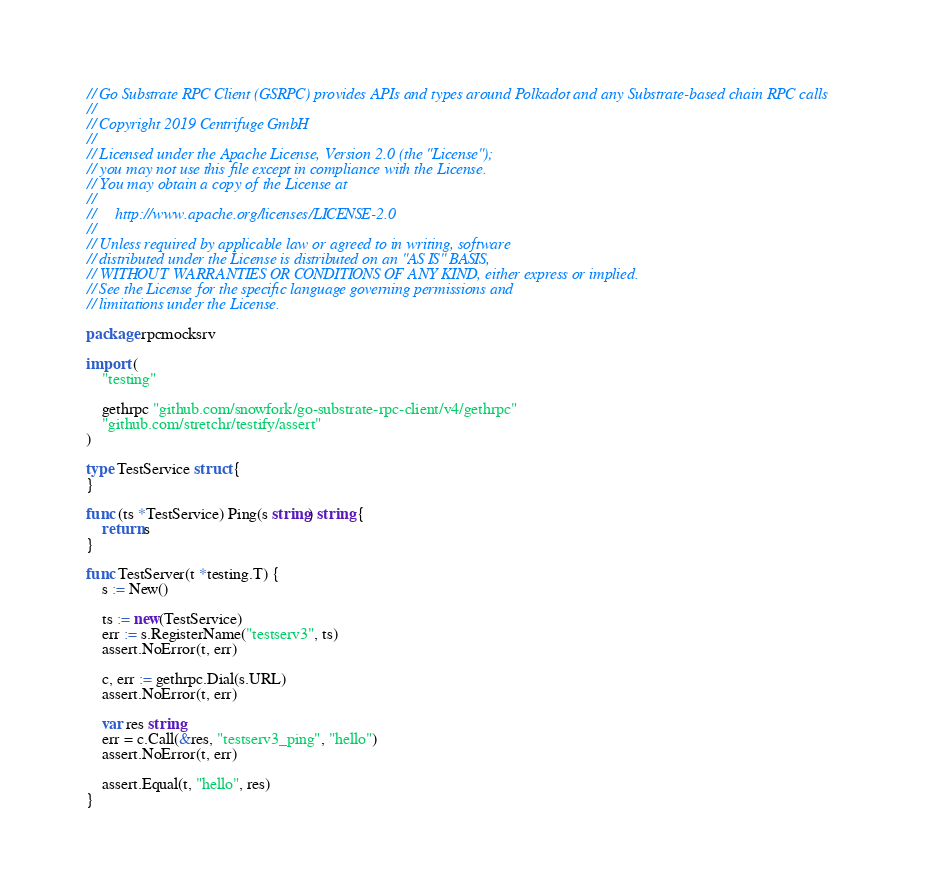Convert code to text. <code><loc_0><loc_0><loc_500><loc_500><_Go_>// Go Substrate RPC Client (GSRPC) provides APIs and types around Polkadot and any Substrate-based chain RPC calls
//
// Copyright 2019 Centrifuge GmbH
//
// Licensed under the Apache License, Version 2.0 (the "License");
// you may not use this file except in compliance with the License.
// You may obtain a copy of the License at
//
//     http://www.apache.org/licenses/LICENSE-2.0
//
// Unless required by applicable law or agreed to in writing, software
// distributed under the License is distributed on an "AS IS" BASIS,
// WITHOUT WARRANTIES OR CONDITIONS OF ANY KIND, either express or implied.
// See the License for the specific language governing permissions and
// limitations under the License.

package rpcmocksrv

import (
	"testing"

	gethrpc "github.com/snowfork/go-substrate-rpc-client/v4/gethrpc"
	"github.com/stretchr/testify/assert"
)

type TestService struct {
}

func (ts *TestService) Ping(s string) string {
	return s
}

func TestServer(t *testing.T) {
	s := New()

	ts := new(TestService)
	err := s.RegisterName("testserv3", ts)
	assert.NoError(t, err)

	c, err := gethrpc.Dial(s.URL)
	assert.NoError(t, err)

	var res string
	err = c.Call(&res, "testserv3_ping", "hello")
	assert.NoError(t, err)

	assert.Equal(t, "hello", res)
}
</code> 